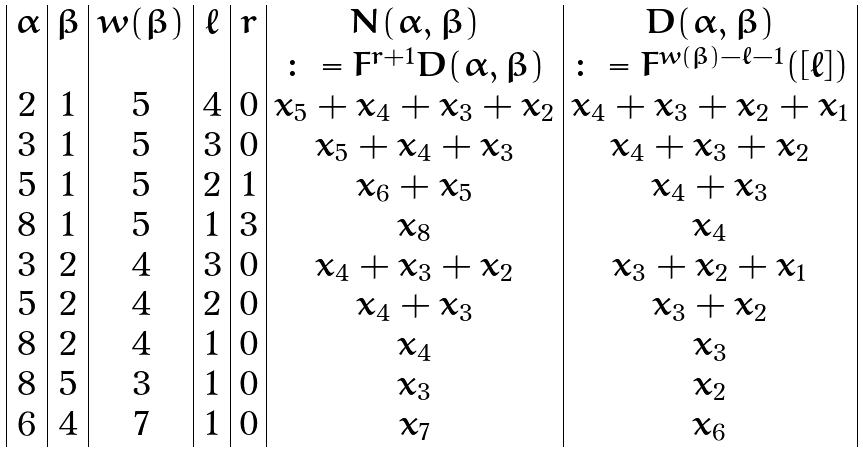<formula> <loc_0><loc_0><loc_500><loc_500>\begin{array} { | c | c | c | c | c | c | c | } \alpha & \beta & w ( \beta ) & \ell & r & N ( \alpha , \beta ) & D ( \alpha , \beta ) \\ & & & & & \colon = F ^ { r + 1 } D ( \alpha , \beta ) & \colon = F ^ { w ( \beta ) - \ell - 1 } ( [ \ell ] ) \\ 2 & 1 & 5 & 4 & 0 & x _ { 5 } + x _ { 4 } + x _ { 3 } + x _ { 2 } & x _ { 4 } + x _ { 3 } + x _ { 2 } + x _ { 1 } \\ 3 & 1 & 5 & 3 & 0 & x _ { 5 } + x _ { 4 } + x _ { 3 } & x _ { 4 } + x _ { 3 } + x _ { 2 } \\ 5 & 1 & 5 & 2 & 1 & x _ { 6 } + x _ { 5 } & x _ { 4 } + x _ { 3 } \\ 8 & 1 & 5 & 1 & 3 & x _ { 8 } & x _ { 4 } \\ 3 & 2 & 4 & 3 & 0 & x _ { 4 } + x _ { 3 } + x _ { 2 } & x _ { 3 } + x _ { 2 } + x _ { 1 } \\ 5 & 2 & 4 & 2 & 0 & x _ { 4 } + x _ { 3 } & x _ { 3 } + x _ { 2 } \\ 8 & 2 & 4 & 1 & 0 & x _ { 4 } & x _ { 3 } \\ 8 & 5 & 3 & 1 & 0 & x _ { 3 } & x _ { 2 } \\ 6 & 4 & 7 & 1 & 0 & x _ { 7 } & x _ { 6 } \\ \end{array}</formula> 